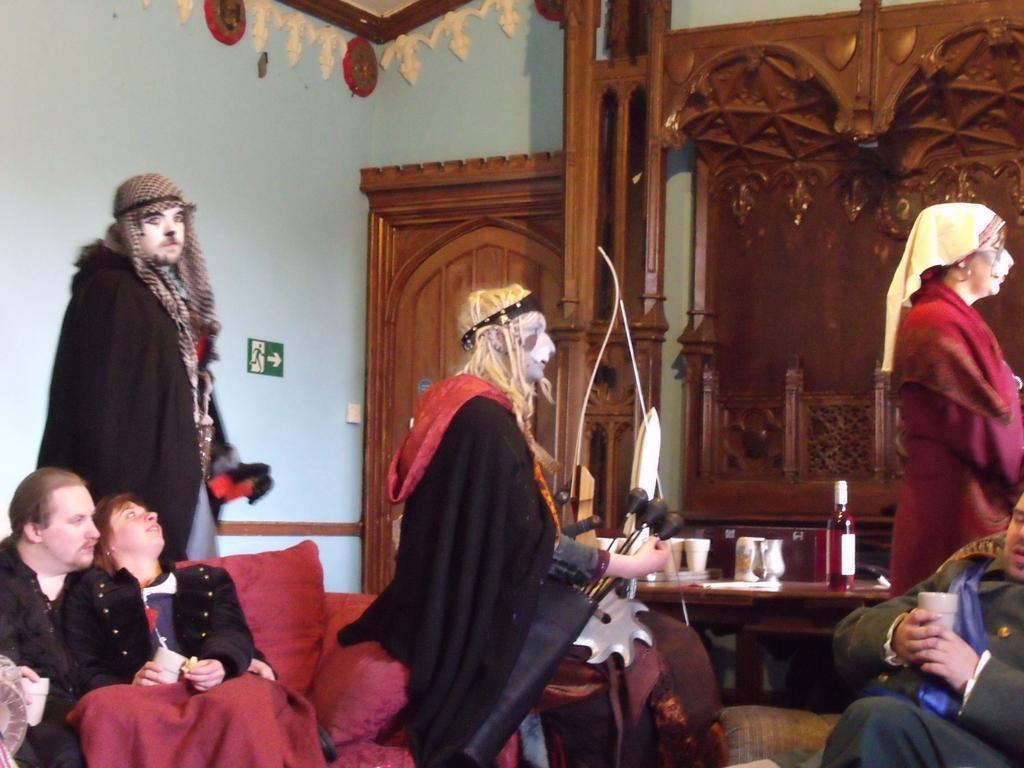Please provide a concise description of this image. In this image we can see some people painted their faces and we can also see some people are sitting. we can see door, bottle, wall and wooden objects. 